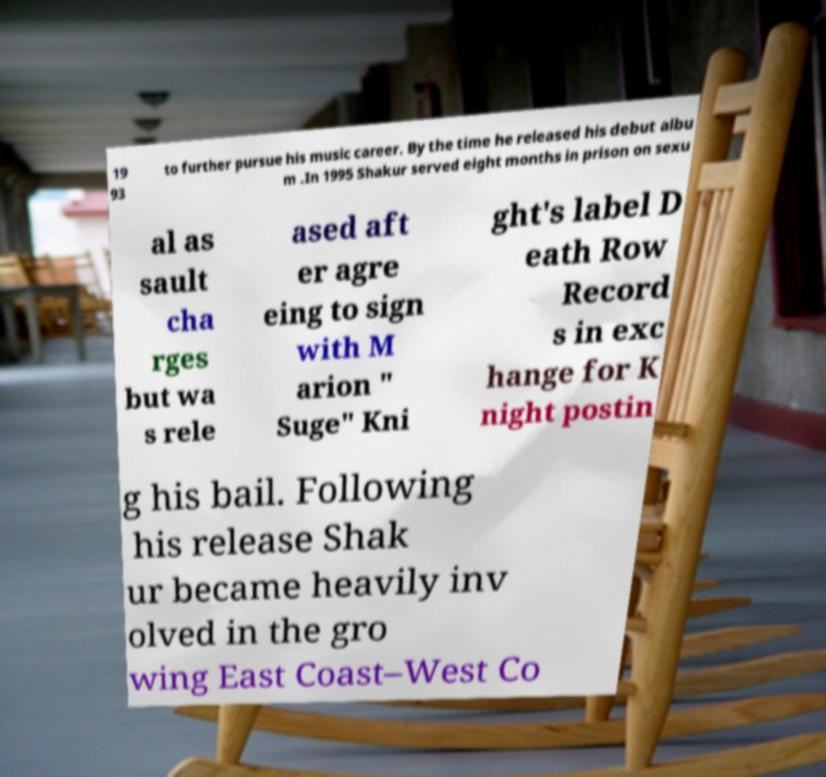Can you read and provide the text displayed in the image?This photo seems to have some interesting text. Can you extract and type it out for me? 19 93 to further pursue his music career. By the time he released his debut albu m .In 1995 Shakur served eight months in prison on sexu al as sault cha rges but wa s rele ased aft er agre eing to sign with M arion " Suge" Kni ght's label D eath Row Record s in exc hange for K night postin g his bail. Following his release Shak ur became heavily inv olved in the gro wing East Coast–West Co 